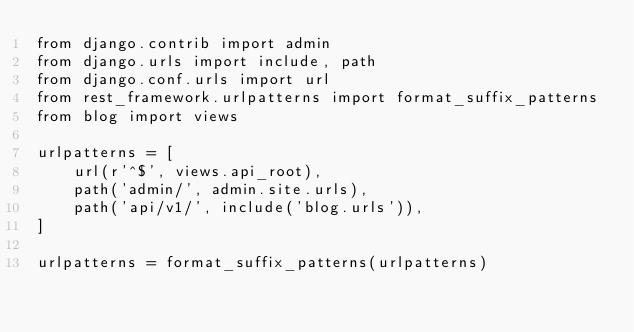Convert code to text. <code><loc_0><loc_0><loc_500><loc_500><_Python_>from django.contrib import admin
from django.urls import include, path
from django.conf.urls import url
from rest_framework.urlpatterns import format_suffix_patterns
from blog import views

urlpatterns = [
    url(r'^$', views.api_root),
    path('admin/', admin.site.urls),
    path('api/v1/', include('blog.urls')),
]

urlpatterns = format_suffix_patterns(urlpatterns)
</code> 